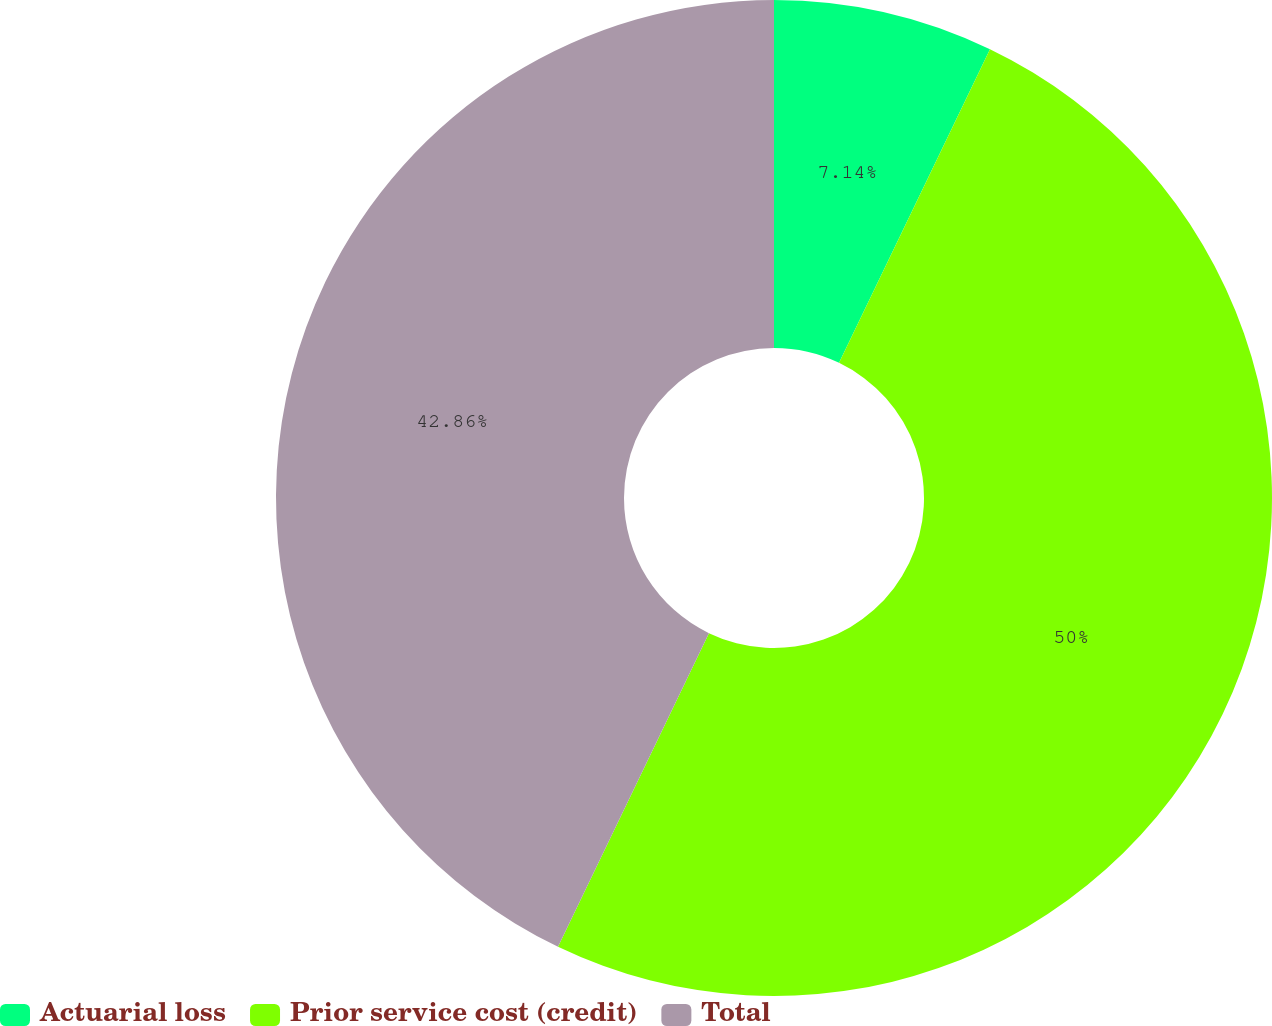Convert chart. <chart><loc_0><loc_0><loc_500><loc_500><pie_chart><fcel>Actuarial loss<fcel>Prior service cost (credit)<fcel>Total<nl><fcel>7.14%<fcel>50.0%<fcel>42.86%<nl></chart> 